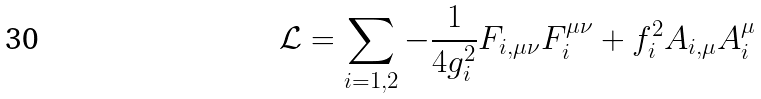Convert formula to latex. <formula><loc_0><loc_0><loc_500><loc_500>\mathcal { L } = \sum _ { i = 1 , 2 } - \frac { 1 } { 4 g _ { i } ^ { 2 } } F _ { i , \mu \nu } F ^ { \mu \nu } _ { i } + f _ { i } ^ { 2 } A _ { i , \mu } A ^ { \mu } _ { i }</formula> 